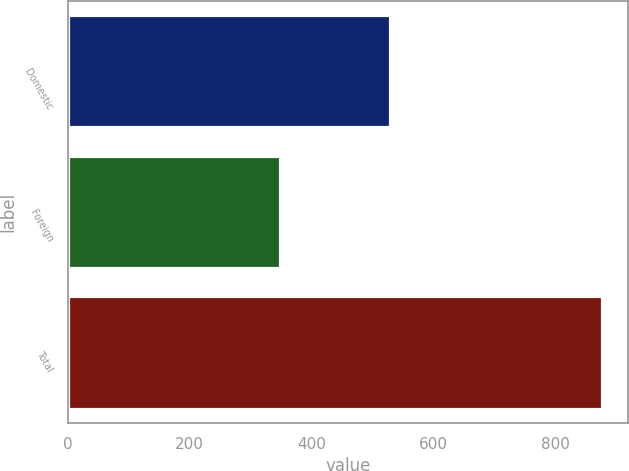<chart> <loc_0><loc_0><loc_500><loc_500><bar_chart><fcel>Domestic<fcel>Foreign<fcel>Total<nl><fcel>528.2<fcel>347.8<fcel>876<nl></chart> 